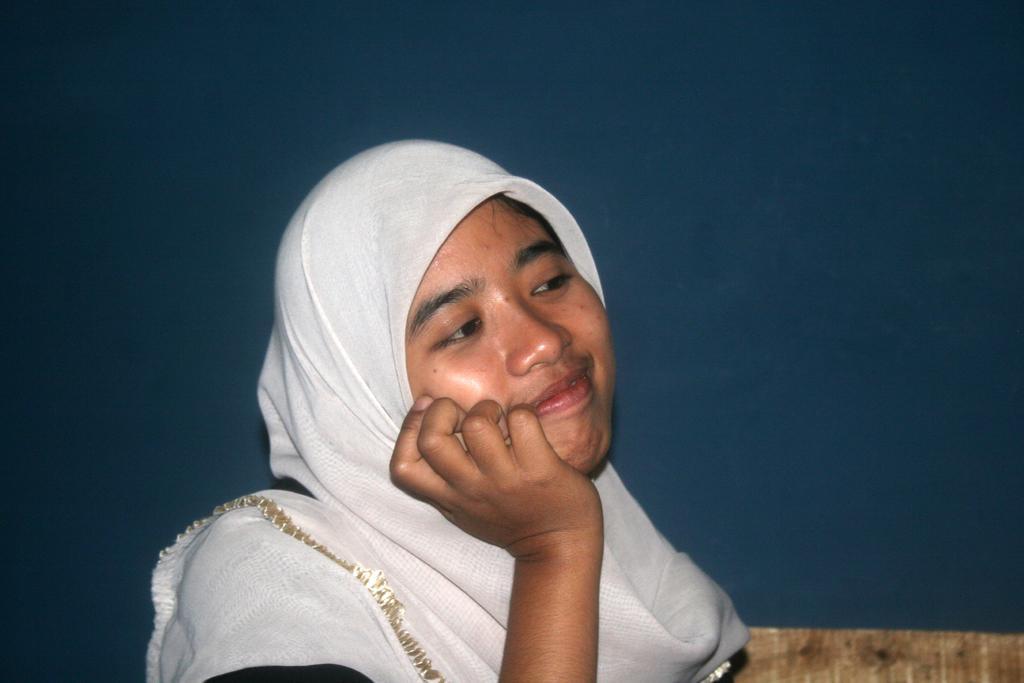Describe this image in one or two sentences. In this image we can see a person smiling and wearing a white scarf around her head and in the background, we can see the wall. 